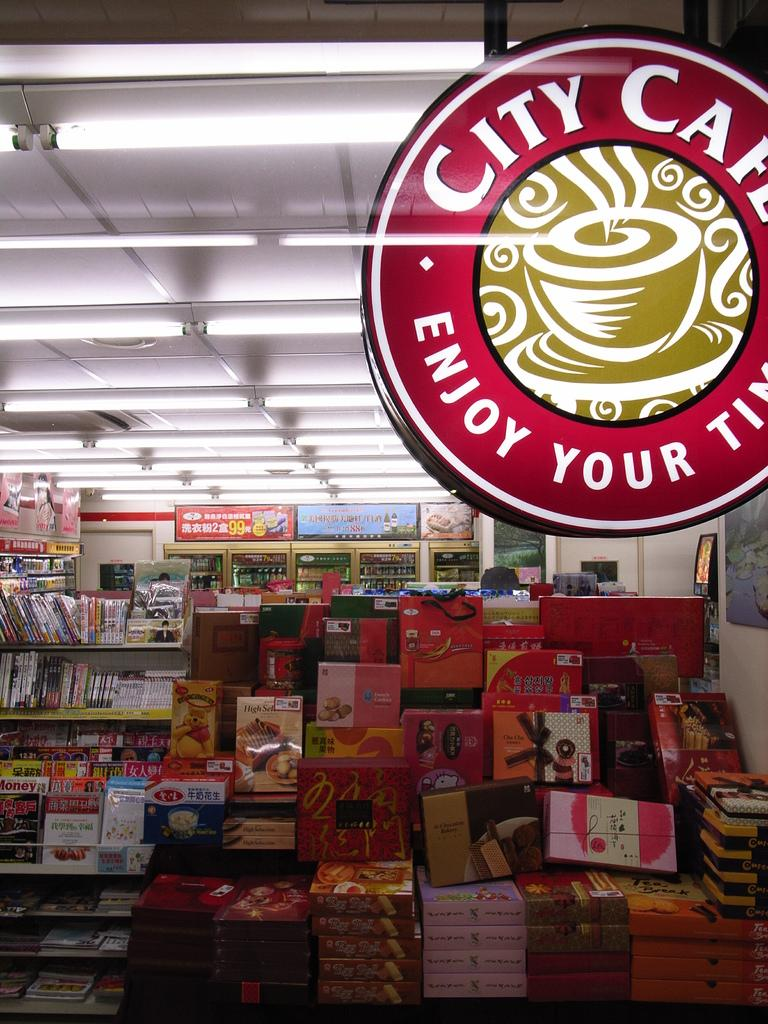<image>
Write a terse but informative summary of the picture. A City Cafe sign hangs above a mountain of chocolate boxes. 